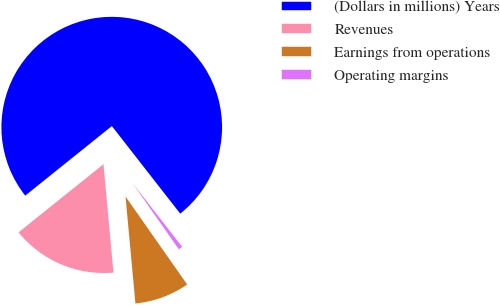<chart> <loc_0><loc_0><loc_500><loc_500><pie_chart><fcel>(Dollars in millions) Years<fcel>Revenues<fcel>Earnings from operations<fcel>Operating margins<nl><fcel>75.22%<fcel>15.7%<fcel>8.26%<fcel>0.82%<nl></chart> 